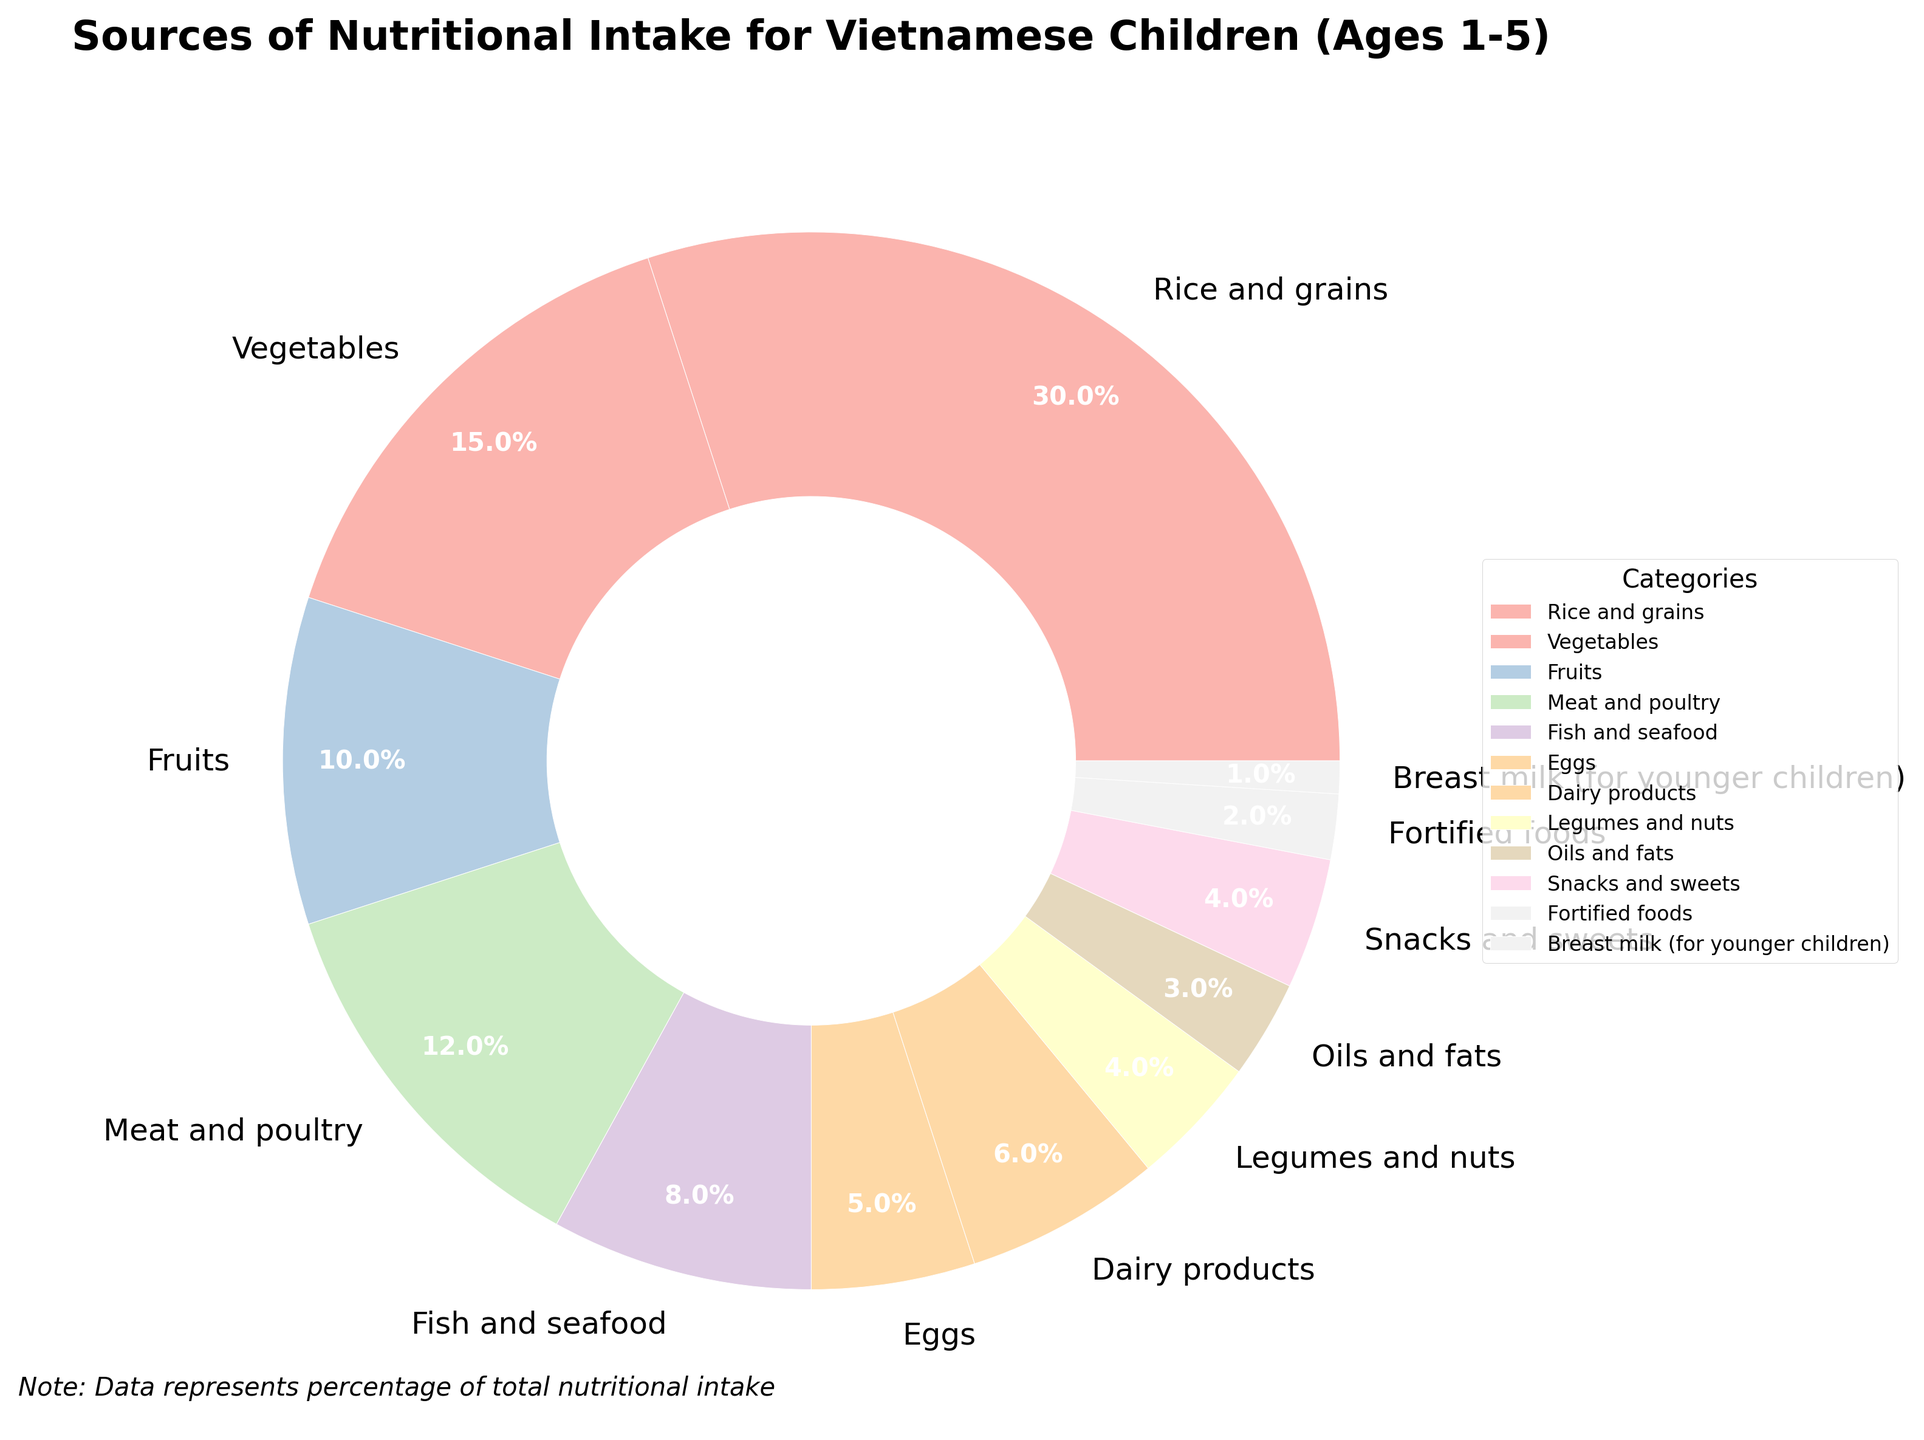What category has the largest percentage of nutritional intake for Vietnamese children aged 1-5? Look at the pie chart and identify the category with the largest wedge. The largest percentage is represented by "Rice and grains" with 30%.
Answer: Rice and grains What category contributes the least to the nutritional intake? Identify the smallest wedge in the pie chart, which corresponds to "Breast milk (for younger children)" with 1%.
Answer: Breast milk (for younger children) What is the total percentage of nutritional intake coming from "Meat and poultry" and "Fish and seafood"? Add the percentages of "Meat and poultry" (12%) and "Fish and seafood" (8%). The sum is 12% + 8% = 20%.
Answer: 20% Does the combined percentage of "Vegetables" and "Fruits" surpass the percentage of "Rice and grains"? Add the percentages of "Vegetables" (15%) and "Fruits" (10%), which gives 25%, and compare it to "Rice and grains" with 30%. 25% is less than 30%.
Answer: No Which is higher, the percentage from "Legumes and nuts" or "Snacks and sweets"? Compare the two percentages: "Legumes and nuts" (4%) and "Snacks and sweets" (4%). Both are equal, so neither is higher.
Answer: Equal What is the combined percentage of all sources of protein (Meat and poultry, Fish and seafood, Eggs, and Legumes and nuts)? Add the percentages of "Meat and poultry" (12%), "Fish and seafood" (8%), "Eggs" (5%), and "Legumes and nuts" (4%). The sum is 12% + 8% + 5% + 4% = 29%.
Answer: 29% If the combined percentage of "Vegetables" and "Fruits" is 25%, what percentage does the remaining categories contribute? Subtract the combined percentage of "Vegetables" and "Fruits" (25%) from the total (100%). The remaining percentage is 100% - 25% = 75%.
Answer: 75% Which color represents the source with the lowest percentage? Look at the pie chart for the wedge with the smallest percentage (1%), which is "Breast milk (for younger children)". Identify the color of this wedge.
Answer: Check the color of the "Breast milk (for younger children)" wedge Is the percentage of "Dairy products" higher than "Oils and fats"? Compare the two percentages: "Dairy products" (6%) and "Oils and fats" (3%). "Dairy products" is higher.
Answer: Yes What is the difference in percentage between "Vegetables" and "Fruits"? Subtract the percentage of "Fruits" (10%) from "Vegetables" (15%). The difference is 15% - 10% = 5%.
Answer: 5% 